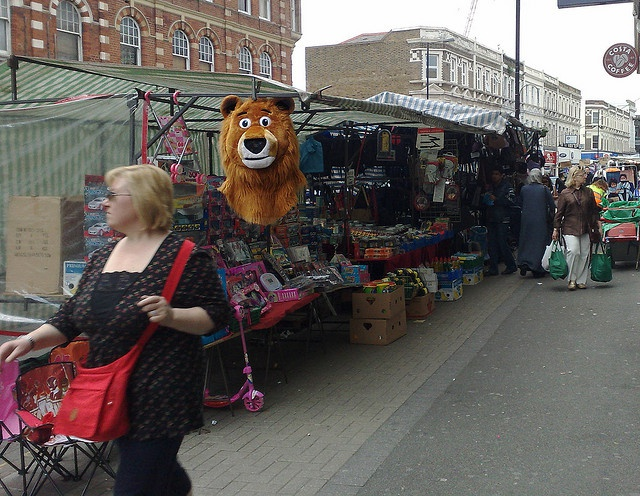Describe the objects in this image and their specific colors. I can see people in darkgray, black, maroon, and gray tones, teddy bear in darkgray, maroon, brown, and black tones, chair in darkgray, black, maroon, and gray tones, handbag in darkgray, brown, black, and maroon tones, and people in darkgray, black, and gray tones in this image. 